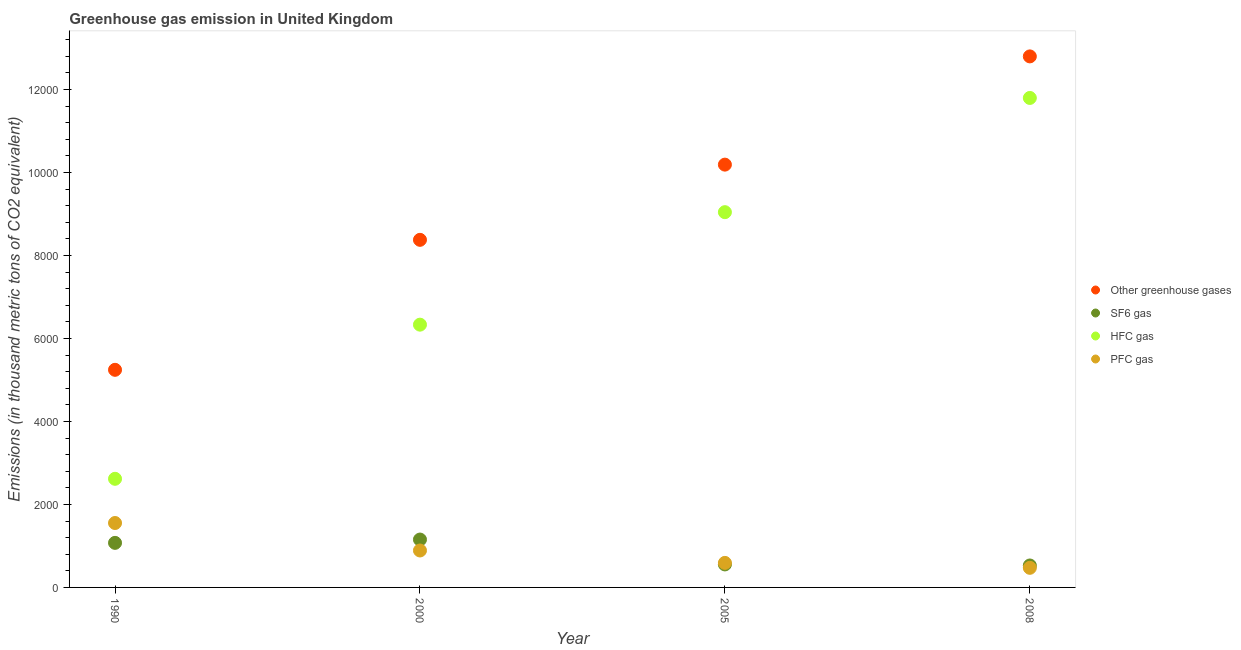What is the emission of pfc gas in 1990?
Ensure brevity in your answer.  1552.5. Across all years, what is the maximum emission of greenhouse gases?
Make the answer very short. 1.28e+04. Across all years, what is the minimum emission of greenhouse gases?
Offer a terse response. 5244.2. In which year was the emission of sf6 gas maximum?
Ensure brevity in your answer.  2000. What is the total emission of greenhouse gases in the graph?
Your answer should be compact. 3.66e+04. What is the difference between the emission of greenhouse gases in 1990 and that in 2008?
Your response must be concise. -7553.1. What is the difference between the emission of pfc gas in 1990 and the emission of greenhouse gases in 2000?
Your answer should be compact. -6824.2. What is the average emission of sf6 gas per year?
Offer a very short reply. 827.77. In the year 2005, what is the difference between the emission of pfc gas and emission of greenhouse gases?
Provide a succinct answer. -9597.6. What is the ratio of the emission of greenhouse gases in 1990 to that in 2000?
Offer a terse response. 0.63. Is the difference between the emission of greenhouse gases in 1990 and 2005 greater than the difference between the emission of hfc gas in 1990 and 2005?
Your answer should be compact. Yes. What is the difference between the highest and the second highest emission of sf6 gas?
Your answer should be compact. 80.2. What is the difference between the highest and the lowest emission of greenhouse gases?
Keep it short and to the point. 7553.1. Is it the case that in every year, the sum of the emission of greenhouse gases and emission of sf6 gas is greater than the emission of hfc gas?
Your response must be concise. Yes. Is the emission of greenhouse gases strictly greater than the emission of pfc gas over the years?
Your response must be concise. Yes. Is the emission of greenhouse gases strictly less than the emission of pfc gas over the years?
Offer a terse response. No. How many dotlines are there?
Make the answer very short. 4. Are the values on the major ticks of Y-axis written in scientific E-notation?
Offer a terse response. No. Where does the legend appear in the graph?
Make the answer very short. Center right. How many legend labels are there?
Give a very brief answer. 4. How are the legend labels stacked?
Your answer should be compact. Vertical. What is the title of the graph?
Ensure brevity in your answer.  Greenhouse gas emission in United Kingdom. What is the label or title of the X-axis?
Make the answer very short. Year. What is the label or title of the Y-axis?
Provide a short and direct response. Emissions (in thousand metric tons of CO2 equivalent). What is the Emissions (in thousand metric tons of CO2 equivalent) in Other greenhouse gases in 1990?
Your answer should be very brief. 5244.2. What is the Emissions (in thousand metric tons of CO2 equivalent) in SF6 gas in 1990?
Provide a succinct answer. 1073.9. What is the Emissions (in thousand metric tons of CO2 equivalent) in HFC gas in 1990?
Your response must be concise. 2617.8. What is the Emissions (in thousand metric tons of CO2 equivalent) in PFC gas in 1990?
Provide a succinct answer. 1552.5. What is the Emissions (in thousand metric tons of CO2 equivalent) in Other greenhouse gases in 2000?
Provide a succinct answer. 8376.7. What is the Emissions (in thousand metric tons of CO2 equivalent) of SF6 gas in 2000?
Give a very brief answer. 1154.1. What is the Emissions (in thousand metric tons of CO2 equivalent) of HFC gas in 2000?
Give a very brief answer. 6332.5. What is the Emissions (in thousand metric tons of CO2 equivalent) in PFC gas in 2000?
Your response must be concise. 890.1. What is the Emissions (in thousand metric tons of CO2 equivalent) of Other greenhouse gases in 2005?
Your response must be concise. 1.02e+04. What is the Emissions (in thousand metric tons of CO2 equivalent) in SF6 gas in 2005?
Provide a short and direct response. 554.2. What is the Emissions (in thousand metric tons of CO2 equivalent) of HFC gas in 2005?
Provide a short and direct response. 9043.4. What is the Emissions (in thousand metric tons of CO2 equivalent) of PFC gas in 2005?
Ensure brevity in your answer.  591.4. What is the Emissions (in thousand metric tons of CO2 equivalent) of Other greenhouse gases in 2008?
Your response must be concise. 1.28e+04. What is the Emissions (in thousand metric tons of CO2 equivalent) of SF6 gas in 2008?
Provide a succinct answer. 528.9. What is the Emissions (in thousand metric tons of CO2 equivalent) of HFC gas in 2008?
Give a very brief answer. 1.18e+04. What is the Emissions (in thousand metric tons of CO2 equivalent) of PFC gas in 2008?
Your answer should be very brief. 472.4. Across all years, what is the maximum Emissions (in thousand metric tons of CO2 equivalent) of Other greenhouse gases?
Your answer should be compact. 1.28e+04. Across all years, what is the maximum Emissions (in thousand metric tons of CO2 equivalent) of SF6 gas?
Offer a very short reply. 1154.1. Across all years, what is the maximum Emissions (in thousand metric tons of CO2 equivalent) in HFC gas?
Keep it short and to the point. 1.18e+04. Across all years, what is the maximum Emissions (in thousand metric tons of CO2 equivalent) of PFC gas?
Keep it short and to the point. 1552.5. Across all years, what is the minimum Emissions (in thousand metric tons of CO2 equivalent) in Other greenhouse gases?
Provide a succinct answer. 5244.2. Across all years, what is the minimum Emissions (in thousand metric tons of CO2 equivalent) of SF6 gas?
Keep it short and to the point. 528.9. Across all years, what is the minimum Emissions (in thousand metric tons of CO2 equivalent) of HFC gas?
Offer a very short reply. 2617.8. Across all years, what is the minimum Emissions (in thousand metric tons of CO2 equivalent) of PFC gas?
Offer a terse response. 472.4. What is the total Emissions (in thousand metric tons of CO2 equivalent) of Other greenhouse gases in the graph?
Provide a succinct answer. 3.66e+04. What is the total Emissions (in thousand metric tons of CO2 equivalent) in SF6 gas in the graph?
Offer a very short reply. 3311.1. What is the total Emissions (in thousand metric tons of CO2 equivalent) in HFC gas in the graph?
Keep it short and to the point. 2.98e+04. What is the total Emissions (in thousand metric tons of CO2 equivalent) in PFC gas in the graph?
Give a very brief answer. 3506.4. What is the difference between the Emissions (in thousand metric tons of CO2 equivalent) in Other greenhouse gases in 1990 and that in 2000?
Your answer should be very brief. -3132.5. What is the difference between the Emissions (in thousand metric tons of CO2 equivalent) in SF6 gas in 1990 and that in 2000?
Offer a terse response. -80.2. What is the difference between the Emissions (in thousand metric tons of CO2 equivalent) in HFC gas in 1990 and that in 2000?
Offer a very short reply. -3714.7. What is the difference between the Emissions (in thousand metric tons of CO2 equivalent) of PFC gas in 1990 and that in 2000?
Keep it short and to the point. 662.4. What is the difference between the Emissions (in thousand metric tons of CO2 equivalent) of Other greenhouse gases in 1990 and that in 2005?
Your answer should be compact. -4944.8. What is the difference between the Emissions (in thousand metric tons of CO2 equivalent) in SF6 gas in 1990 and that in 2005?
Provide a succinct answer. 519.7. What is the difference between the Emissions (in thousand metric tons of CO2 equivalent) of HFC gas in 1990 and that in 2005?
Offer a very short reply. -6425.6. What is the difference between the Emissions (in thousand metric tons of CO2 equivalent) of PFC gas in 1990 and that in 2005?
Ensure brevity in your answer.  961.1. What is the difference between the Emissions (in thousand metric tons of CO2 equivalent) of Other greenhouse gases in 1990 and that in 2008?
Offer a terse response. -7553.1. What is the difference between the Emissions (in thousand metric tons of CO2 equivalent) of SF6 gas in 1990 and that in 2008?
Provide a succinct answer. 545. What is the difference between the Emissions (in thousand metric tons of CO2 equivalent) of HFC gas in 1990 and that in 2008?
Provide a succinct answer. -9178.2. What is the difference between the Emissions (in thousand metric tons of CO2 equivalent) of PFC gas in 1990 and that in 2008?
Provide a succinct answer. 1080.1. What is the difference between the Emissions (in thousand metric tons of CO2 equivalent) of Other greenhouse gases in 2000 and that in 2005?
Your response must be concise. -1812.3. What is the difference between the Emissions (in thousand metric tons of CO2 equivalent) in SF6 gas in 2000 and that in 2005?
Provide a short and direct response. 599.9. What is the difference between the Emissions (in thousand metric tons of CO2 equivalent) in HFC gas in 2000 and that in 2005?
Offer a very short reply. -2710.9. What is the difference between the Emissions (in thousand metric tons of CO2 equivalent) of PFC gas in 2000 and that in 2005?
Provide a succinct answer. 298.7. What is the difference between the Emissions (in thousand metric tons of CO2 equivalent) in Other greenhouse gases in 2000 and that in 2008?
Provide a short and direct response. -4420.6. What is the difference between the Emissions (in thousand metric tons of CO2 equivalent) in SF6 gas in 2000 and that in 2008?
Keep it short and to the point. 625.2. What is the difference between the Emissions (in thousand metric tons of CO2 equivalent) of HFC gas in 2000 and that in 2008?
Give a very brief answer. -5463.5. What is the difference between the Emissions (in thousand metric tons of CO2 equivalent) in PFC gas in 2000 and that in 2008?
Your answer should be compact. 417.7. What is the difference between the Emissions (in thousand metric tons of CO2 equivalent) of Other greenhouse gases in 2005 and that in 2008?
Provide a succinct answer. -2608.3. What is the difference between the Emissions (in thousand metric tons of CO2 equivalent) of SF6 gas in 2005 and that in 2008?
Your answer should be very brief. 25.3. What is the difference between the Emissions (in thousand metric tons of CO2 equivalent) of HFC gas in 2005 and that in 2008?
Ensure brevity in your answer.  -2752.6. What is the difference between the Emissions (in thousand metric tons of CO2 equivalent) of PFC gas in 2005 and that in 2008?
Your answer should be very brief. 119. What is the difference between the Emissions (in thousand metric tons of CO2 equivalent) of Other greenhouse gases in 1990 and the Emissions (in thousand metric tons of CO2 equivalent) of SF6 gas in 2000?
Offer a very short reply. 4090.1. What is the difference between the Emissions (in thousand metric tons of CO2 equivalent) in Other greenhouse gases in 1990 and the Emissions (in thousand metric tons of CO2 equivalent) in HFC gas in 2000?
Your response must be concise. -1088.3. What is the difference between the Emissions (in thousand metric tons of CO2 equivalent) of Other greenhouse gases in 1990 and the Emissions (in thousand metric tons of CO2 equivalent) of PFC gas in 2000?
Offer a very short reply. 4354.1. What is the difference between the Emissions (in thousand metric tons of CO2 equivalent) in SF6 gas in 1990 and the Emissions (in thousand metric tons of CO2 equivalent) in HFC gas in 2000?
Your answer should be compact. -5258.6. What is the difference between the Emissions (in thousand metric tons of CO2 equivalent) of SF6 gas in 1990 and the Emissions (in thousand metric tons of CO2 equivalent) of PFC gas in 2000?
Provide a succinct answer. 183.8. What is the difference between the Emissions (in thousand metric tons of CO2 equivalent) in HFC gas in 1990 and the Emissions (in thousand metric tons of CO2 equivalent) in PFC gas in 2000?
Give a very brief answer. 1727.7. What is the difference between the Emissions (in thousand metric tons of CO2 equivalent) in Other greenhouse gases in 1990 and the Emissions (in thousand metric tons of CO2 equivalent) in SF6 gas in 2005?
Ensure brevity in your answer.  4690. What is the difference between the Emissions (in thousand metric tons of CO2 equivalent) in Other greenhouse gases in 1990 and the Emissions (in thousand metric tons of CO2 equivalent) in HFC gas in 2005?
Offer a very short reply. -3799.2. What is the difference between the Emissions (in thousand metric tons of CO2 equivalent) in Other greenhouse gases in 1990 and the Emissions (in thousand metric tons of CO2 equivalent) in PFC gas in 2005?
Give a very brief answer. 4652.8. What is the difference between the Emissions (in thousand metric tons of CO2 equivalent) of SF6 gas in 1990 and the Emissions (in thousand metric tons of CO2 equivalent) of HFC gas in 2005?
Give a very brief answer. -7969.5. What is the difference between the Emissions (in thousand metric tons of CO2 equivalent) of SF6 gas in 1990 and the Emissions (in thousand metric tons of CO2 equivalent) of PFC gas in 2005?
Your answer should be very brief. 482.5. What is the difference between the Emissions (in thousand metric tons of CO2 equivalent) of HFC gas in 1990 and the Emissions (in thousand metric tons of CO2 equivalent) of PFC gas in 2005?
Your answer should be very brief. 2026.4. What is the difference between the Emissions (in thousand metric tons of CO2 equivalent) in Other greenhouse gases in 1990 and the Emissions (in thousand metric tons of CO2 equivalent) in SF6 gas in 2008?
Your answer should be very brief. 4715.3. What is the difference between the Emissions (in thousand metric tons of CO2 equivalent) in Other greenhouse gases in 1990 and the Emissions (in thousand metric tons of CO2 equivalent) in HFC gas in 2008?
Provide a short and direct response. -6551.8. What is the difference between the Emissions (in thousand metric tons of CO2 equivalent) of Other greenhouse gases in 1990 and the Emissions (in thousand metric tons of CO2 equivalent) of PFC gas in 2008?
Ensure brevity in your answer.  4771.8. What is the difference between the Emissions (in thousand metric tons of CO2 equivalent) in SF6 gas in 1990 and the Emissions (in thousand metric tons of CO2 equivalent) in HFC gas in 2008?
Provide a succinct answer. -1.07e+04. What is the difference between the Emissions (in thousand metric tons of CO2 equivalent) of SF6 gas in 1990 and the Emissions (in thousand metric tons of CO2 equivalent) of PFC gas in 2008?
Provide a succinct answer. 601.5. What is the difference between the Emissions (in thousand metric tons of CO2 equivalent) in HFC gas in 1990 and the Emissions (in thousand metric tons of CO2 equivalent) in PFC gas in 2008?
Give a very brief answer. 2145.4. What is the difference between the Emissions (in thousand metric tons of CO2 equivalent) of Other greenhouse gases in 2000 and the Emissions (in thousand metric tons of CO2 equivalent) of SF6 gas in 2005?
Ensure brevity in your answer.  7822.5. What is the difference between the Emissions (in thousand metric tons of CO2 equivalent) in Other greenhouse gases in 2000 and the Emissions (in thousand metric tons of CO2 equivalent) in HFC gas in 2005?
Your answer should be very brief. -666.7. What is the difference between the Emissions (in thousand metric tons of CO2 equivalent) of Other greenhouse gases in 2000 and the Emissions (in thousand metric tons of CO2 equivalent) of PFC gas in 2005?
Provide a short and direct response. 7785.3. What is the difference between the Emissions (in thousand metric tons of CO2 equivalent) of SF6 gas in 2000 and the Emissions (in thousand metric tons of CO2 equivalent) of HFC gas in 2005?
Provide a short and direct response. -7889.3. What is the difference between the Emissions (in thousand metric tons of CO2 equivalent) of SF6 gas in 2000 and the Emissions (in thousand metric tons of CO2 equivalent) of PFC gas in 2005?
Give a very brief answer. 562.7. What is the difference between the Emissions (in thousand metric tons of CO2 equivalent) in HFC gas in 2000 and the Emissions (in thousand metric tons of CO2 equivalent) in PFC gas in 2005?
Give a very brief answer. 5741.1. What is the difference between the Emissions (in thousand metric tons of CO2 equivalent) in Other greenhouse gases in 2000 and the Emissions (in thousand metric tons of CO2 equivalent) in SF6 gas in 2008?
Offer a very short reply. 7847.8. What is the difference between the Emissions (in thousand metric tons of CO2 equivalent) of Other greenhouse gases in 2000 and the Emissions (in thousand metric tons of CO2 equivalent) of HFC gas in 2008?
Offer a terse response. -3419.3. What is the difference between the Emissions (in thousand metric tons of CO2 equivalent) of Other greenhouse gases in 2000 and the Emissions (in thousand metric tons of CO2 equivalent) of PFC gas in 2008?
Provide a short and direct response. 7904.3. What is the difference between the Emissions (in thousand metric tons of CO2 equivalent) in SF6 gas in 2000 and the Emissions (in thousand metric tons of CO2 equivalent) in HFC gas in 2008?
Provide a short and direct response. -1.06e+04. What is the difference between the Emissions (in thousand metric tons of CO2 equivalent) of SF6 gas in 2000 and the Emissions (in thousand metric tons of CO2 equivalent) of PFC gas in 2008?
Provide a succinct answer. 681.7. What is the difference between the Emissions (in thousand metric tons of CO2 equivalent) in HFC gas in 2000 and the Emissions (in thousand metric tons of CO2 equivalent) in PFC gas in 2008?
Your response must be concise. 5860.1. What is the difference between the Emissions (in thousand metric tons of CO2 equivalent) of Other greenhouse gases in 2005 and the Emissions (in thousand metric tons of CO2 equivalent) of SF6 gas in 2008?
Offer a very short reply. 9660.1. What is the difference between the Emissions (in thousand metric tons of CO2 equivalent) of Other greenhouse gases in 2005 and the Emissions (in thousand metric tons of CO2 equivalent) of HFC gas in 2008?
Your answer should be very brief. -1607. What is the difference between the Emissions (in thousand metric tons of CO2 equivalent) in Other greenhouse gases in 2005 and the Emissions (in thousand metric tons of CO2 equivalent) in PFC gas in 2008?
Make the answer very short. 9716.6. What is the difference between the Emissions (in thousand metric tons of CO2 equivalent) in SF6 gas in 2005 and the Emissions (in thousand metric tons of CO2 equivalent) in HFC gas in 2008?
Provide a succinct answer. -1.12e+04. What is the difference between the Emissions (in thousand metric tons of CO2 equivalent) of SF6 gas in 2005 and the Emissions (in thousand metric tons of CO2 equivalent) of PFC gas in 2008?
Provide a short and direct response. 81.8. What is the difference between the Emissions (in thousand metric tons of CO2 equivalent) of HFC gas in 2005 and the Emissions (in thousand metric tons of CO2 equivalent) of PFC gas in 2008?
Your answer should be compact. 8571. What is the average Emissions (in thousand metric tons of CO2 equivalent) in Other greenhouse gases per year?
Provide a short and direct response. 9151.8. What is the average Emissions (in thousand metric tons of CO2 equivalent) in SF6 gas per year?
Keep it short and to the point. 827.77. What is the average Emissions (in thousand metric tons of CO2 equivalent) in HFC gas per year?
Your answer should be very brief. 7447.43. What is the average Emissions (in thousand metric tons of CO2 equivalent) of PFC gas per year?
Provide a succinct answer. 876.6. In the year 1990, what is the difference between the Emissions (in thousand metric tons of CO2 equivalent) in Other greenhouse gases and Emissions (in thousand metric tons of CO2 equivalent) in SF6 gas?
Make the answer very short. 4170.3. In the year 1990, what is the difference between the Emissions (in thousand metric tons of CO2 equivalent) of Other greenhouse gases and Emissions (in thousand metric tons of CO2 equivalent) of HFC gas?
Offer a terse response. 2626.4. In the year 1990, what is the difference between the Emissions (in thousand metric tons of CO2 equivalent) in Other greenhouse gases and Emissions (in thousand metric tons of CO2 equivalent) in PFC gas?
Give a very brief answer. 3691.7. In the year 1990, what is the difference between the Emissions (in thousand metric tons of CO2 equivalent) in SF6 gas and Emissions (in thousand metric tons of CO2 equivalent) in HFC gas?
Provide a succinct answer. -1543.9. In the year 1990, what is the difference between the Emissions (in thousand metric tons of CO2 equivalent) of SF6 gas and Emissions (in thousand metric tons of CO2 equivalent) of PFC gas?
Your answer should be compact. -478.6. In the year 1990, what is the difference between the Emissions (in thousand metric tons of CO2 equivalent) of HFC gas and Emissions (in thousand metric tons of CO2 equivalent) of PFC gas?
Your answer should be compact. 1065.3. In the year 2000, what is the difference between the Emissions (in thousand metric tons of CO2 equivalent) of Other greenhouse gases and Emissions (in thousand metric tons of CO2 equivalent) of SF6 gas?
Give a very brief answer. 7222.6. In the year 2000, what is the difference between the Emissions (in thousand metric tons of CO2 equivalent) in Other greenhouse gases and Emissions (in thousand metric tons of CO2 equivalent) in HFC gas?
Give a very brief answer. 2044.2. In the year 2000, what is the difference between the Emissions (in thousand metric tons of CO2 equivalent) of Other greenhouse gases and Emissions (in thousand metric tons of CO2 equivalent) of PFC gas?
Your answer should be compact. 7486.6. In the year 2000, what is the difference between the Emissions (in thousand metric tons of CO2 equivalent) of SF6 gas and Emissions (in thousand metric tons of CO2 equivalent) of HFC gas?
Your answer should be very brief. -5178.4. In the year 2000, what is the difference between the Emissions (in thousand metric tons of CO2 equivalent) in SF6 gas and Emissions (in thousand metric tons of CO2 equivalent) in PFC gas?
Ensure brevity in your answer.  264. In the year 2000, what is the difference between the Emissions (in thousand metric tons of CO2 equivalent) of HFC gas and Emissions (in thousand metric tons of CO2 equivalent) of PFC gas?
Keep it short and to the point. 5442.4. In the year 2005, what is the difference between the Emissions (in thousand metric tons of CO2 equivalent) of Other greenhouse gases and Emissions (in thousand metric tons of CO2 equivalent) of SF6 gas?
Your answer should be compact. 9634.8. In the year 2005, what is the difference between the Emissions (in thousand metric tons of CO2 equivalent) of Other greenhouse gases and Emissions (in thousand metric tons of CO2 equivalent) of HFC gas?
Your response must be concise. 1145.6. In the year 2005, what is the difference between the Emissions (in thousand metric tons of CO2 equivalent) of Other greenhouse gases and Emissions (in thousand metric tons of CO2 equivalent) of PFC gas?
Provide a short and direct response. 9597.6. In the year 2005, what is the difference between the Emissions (in thousand metric tons of CO2 equivalent) in SF6 gas and Emissions (in thousand metric tons of CO2 equivalent) in HFC gas?
Your answer should be very brief. -8489.2. In the year 2005, what is the difference between the Emissions (in thousand metric tons of CO2 equivalent) of SF6 gas and Emissions (in thousand metric tons of CO2 equivalent) of PFC gas?
Offer a very short reply. -37.2. In the year 2005, what is the difference between the Emissions (in thousand metric tons of CO2 equivalent) of HFC gas and Emissions (in thousand metric tons of CO2 equivalent) of PFC gas?
Your response must be concise. 8452. In the year 2008, what is the difference between the Emissions (in thousand metric tons of CO2 equivalent) of Other greenhouse gases and Emissions (in thousand metric tons of CO2 equivalent) of SF6 gas?
Provide a succinct answer. 1.23e+04. In the year 2008, what is the difference between the Emissions (in thousand metric tons of CO2 equivalent) in Other greenhouse gases and Emissions (in thousand metric tons of CO2 equivalent) in HFC gas?
Offer a very short reply. 1001.3. In the year 2008, what is the difference between the Emissions (in thousand metric tons of CO2 equivalent) of Other greenhouse gases and Emissions (in thousand metric tons of CO2 equivalent) of PFC gas?
Offer a terse response. 1.23e+04. In the year 2008, what is the difference between the Emissions (in thousand metric tons of CO2 equivalent) in SF6 gas and Emissions (in thousand metric tons of CO2 equivalent) in HFC gas?
Offer a very short reply. -1.13e+04. In the year 2008, what is the difference between the Emissions (in thousand metric tons of CO2 equivalent) of SF6 gas and Emissions (in thousand metric tons of CO2 equivalent) of PFC gas?
Keep it short and to the point. 56.5. In the year 2008, what is the difference between the Emissions (in thousand metric tons of CO2 equivalent) of HFC gas and Emissions (in thousand metric tons of CO2 equivalent) of PFC gas?
Ensure brevity in your answer.  1.13e+04. What is the ratio of the Emissions (in thousand metric tons of CO2 equivalent) of Other greenhouse gases in 1990 to that in 2000?
Make the answer very short. 0.63. What is the ratio of the Emissions (in thousand metric tons of CO2 equivalent) of SF6 gas in 1990 to that in 2000?
Keep it short and to the point. 0.93. What is the ratio of the Emissions (in thousand metric tons of CO2 equivalent) of HFC gas in 1990 to that in 2000?
Provide a succinct answer. 0.41. What is the ratio of the Emissions (in thousand metric tons of CO2 equivalent) of PFC gas in 1990 to that in 2000?
Provide a short and direct response. 1.74. What is the ratio of the Emissions (in thousand metric tons of CO2 equivalent) in Other greenhouse gases in 1990 to that in 2005?
Ensure brevity in your answer.  0.51. What is the ratio of the Emissions (in thousand metric tons of CO2 equivalent) in SF6 gas in 1990 to that in 2005?
Offer a very short reply. 1.94. What is the ratio of the Emissions (in thousand metric tons of CO2 equivalent) in HFC gas in 1990 to that in 2005?
Offer a terse response. 0.29. What is the ratio of the Emissions (in thousand metric tons of CO2 equivalent) in PFC gas in 1990 to that in 2005?
Offer a very short reply. 2.63. What is the ratio of the Emissions (in thousand metric tons of CO2 equivalent) of Other greenhouse gases in 1990 to that in 2008?
Ensure brevity in your answer.  0.41. What is the ratio of the Emissions (in thousand metric tons of CO2 equivalent) in SF6 gas in 1990 to that in 2008?
Your response must be concise. 2.03. What is the ratio of the Emissions (in thousand metric tons of CO2 equivalent) in HFC gas in 1990 to that in 2008?
Keep it short and to the point. 0.22. What is the ratio of the Emissions (in thousand metric tons of CO2 equivalent) of PFC gas in 1990 to that in 2008?
Offer a terse response. 3.29. What is the ratio of the Emissions (in thousand metric tons of CO2 equivalent) in Other greenhouse gases in 2000 to that in 2005?
Provide a succinct answer. 0.82. What is the ratio of the Emissions (in thousand metric tons of CO2 equivalent) in SF6 gas in 2000 to that in 2005?
Your answer should be compact. 2.08. What is the ratio of the Emissions (in thousand metric tons of CO2 equivalent) of HFC gas in 2000 to that in 2005?
Your answer should be very brief. 0.7. What is the ratio of the Emissions (in thousand metric tons of CO2 equivalent) of PFC gas in 2000 to that in 2005?
Keep it short and to the point. 1.51. What is the ratio of the Emissions (in thousand metric tons of CO2 equivalent) in Other greenhouse gases in 2000 to that in 2008?
Provide a short and direct response. 0.65. What is the ratio of the Emissions (in thousand metric tons of CO2 equivalent) of SF6 gas in 2000 to that in 2008?
Give a very brief answer. 2.18. What is the ratio of the Emissions (in thousand metric tons of CO2 equivalent) of HFC gas in 2000 to that in 2008?
Keep it short and to the point. 0.54. What is the ratio of the Emissions (in thousand metric tons of CO2 equivalent) of PFC gas in 2000 to that in 2008?
Keep it short and to the point. 1.88. What is the ratio of the Emissions (in thousand metric tons of CO2 equivalent) in Other greenhouse gases in 2005 to that in 2008?
Keep it short and to the point. 0.8. What is the ratio of the Emissions (in thousand metric tons of CO2 equivalent) of SF6 gas in 2005 to that in 2008?
Your answer should be compact. 1.05. What is the ratio of the Emissions (in thousand metric tons of CO2 equivalent) of HFC gas in 2005 to that in 2008?
Ensure brevity in your answer.  0.77. What is the ratio of the Emissions (in thousand metric tons of CO2 equivalent) in PFC gas in 2005 to that in 2008?
Provide a succinct answer. 1.25. What is the difference between the highest and the second highest Emissions (in thousand metric tons of CO2 equivalent) in Other greenhouse gases?
Give a very brief answer. 2608.3. What is the difference between the highest and the second highest Emissions (in thousand metric tons of CO2 equivalent) in SF6 gas?
Your answer should be very brief. 80.2. What is the difference between the highest and the second highest Emissions (in thousand metric tons of CO2 equivalent) in HFC gas?
Ensure brevity in your answer.  2752.6. What is the difference between the highest and the second highest Emissions (in thousand metric tons of CO2 equivalent) of PFC gas?
Ensure brevity in your answer.  662.4. What is the difference between the highest and the lowest Emissions (in thousand metric tons of CO2 equivalent) in Other greenhouse gases?
Your answer should be very brief. 7553.1. What is the difference between the highest and the lowest Emissions (in thousand metric tons of CO2 equivalent) in SF6 gas?
Give a very brief answer. 625.2. What is the difference between the highest and the lowest Emissions (in thousand metric tons of CO2 equivalent) of HFC gas?
Your response must be concise. 9178.2. What is the difference between the highest and the lowest Emissions (in thousand metric tons of CO2 equivalent) in PFC gas?
Ensure brevity in your answer.  1080.1. 